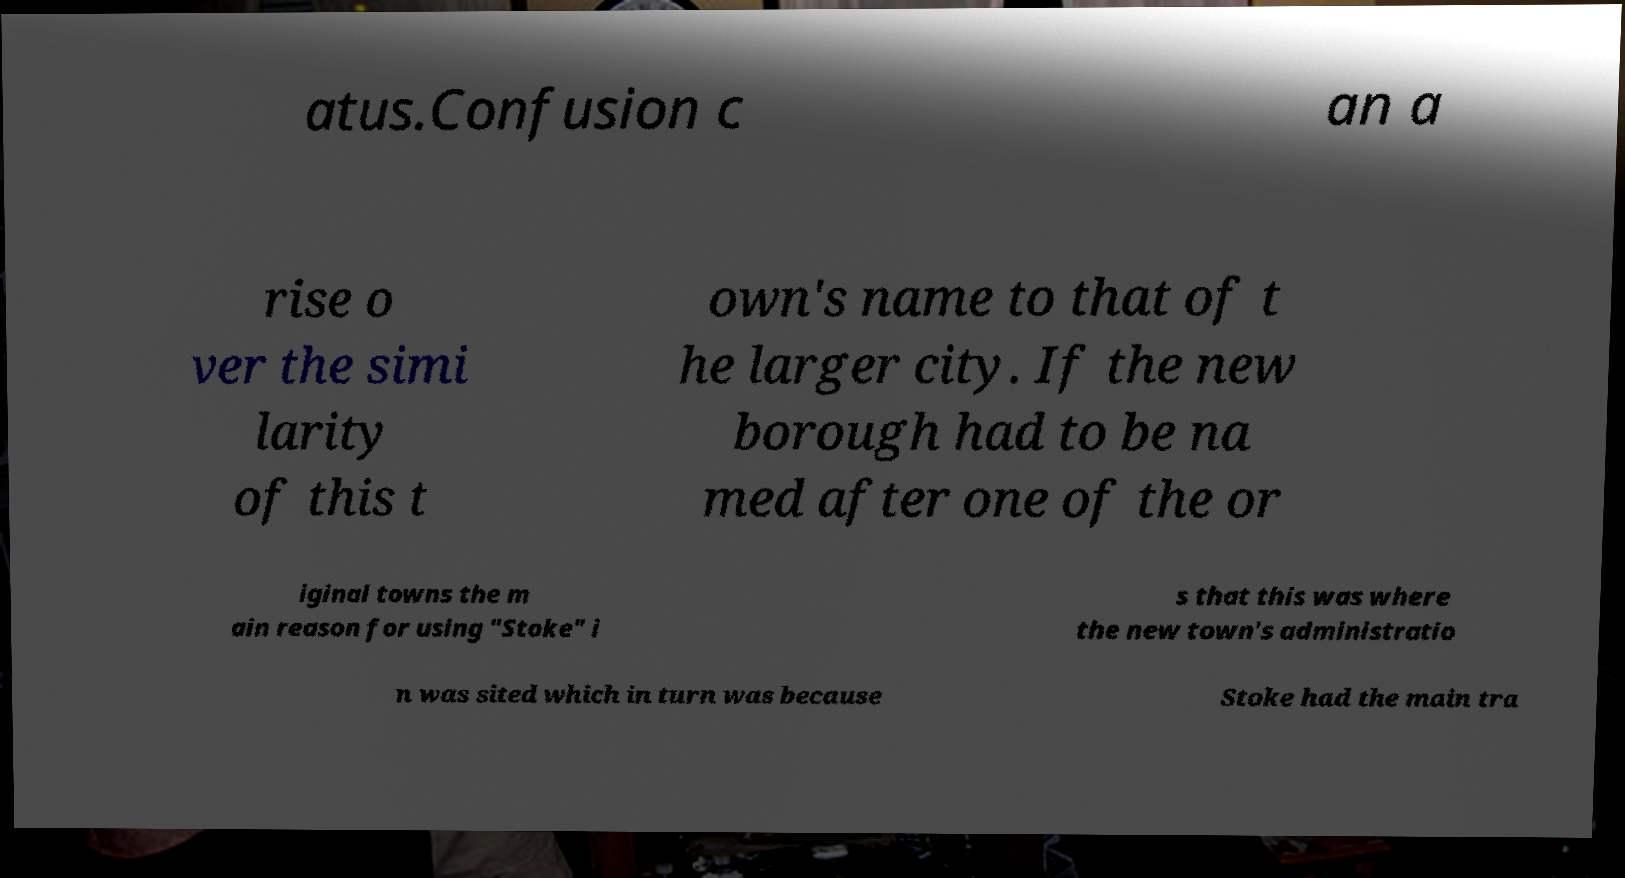Please read and relay the text visible in this image. What does it say? atus.Confusion c an a rise o ver the simi larity of this t own's name to that of t he larger city. If the new borough had to be na med after one of the or iginal towns the m ain reason for using "Stoke" i s that this was where the new town's administratio n was sited which in turn was because Stoke had the main tra 